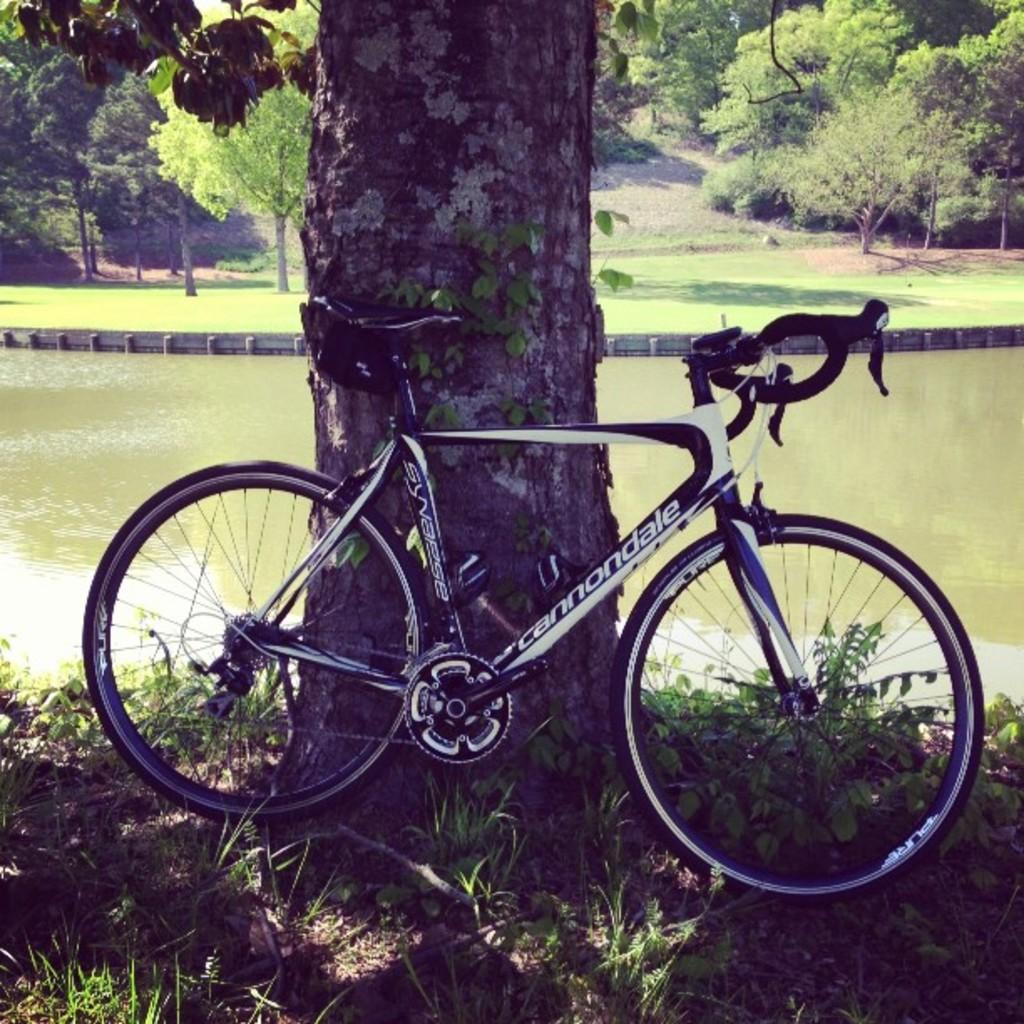Can you describe this image briefly? In the center of the image we can see a bicycle on the grass. In the background we can see the trees, lake and also ground. 